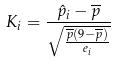Convert formula to latex. <formula><loc_0><loc_0><loc_500><loc_500>K _ { i } = \frac { \hat { p } _ { i } - \overline { p } } { \sqrt { \frac { \overline { p } ( 9 - \overline { p } ) } { e _ { i } } } }</formula> 